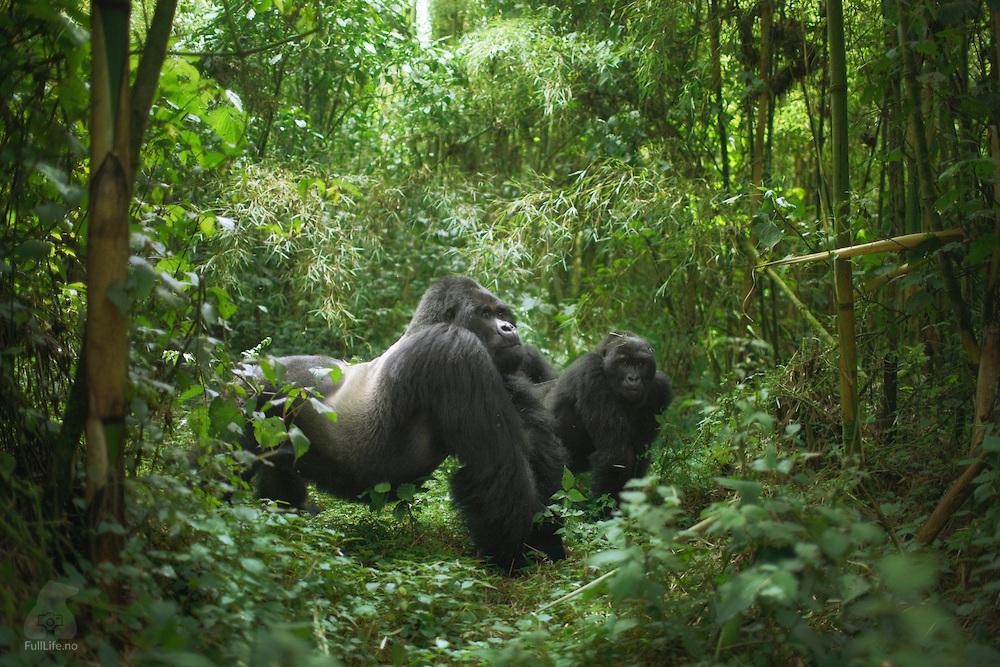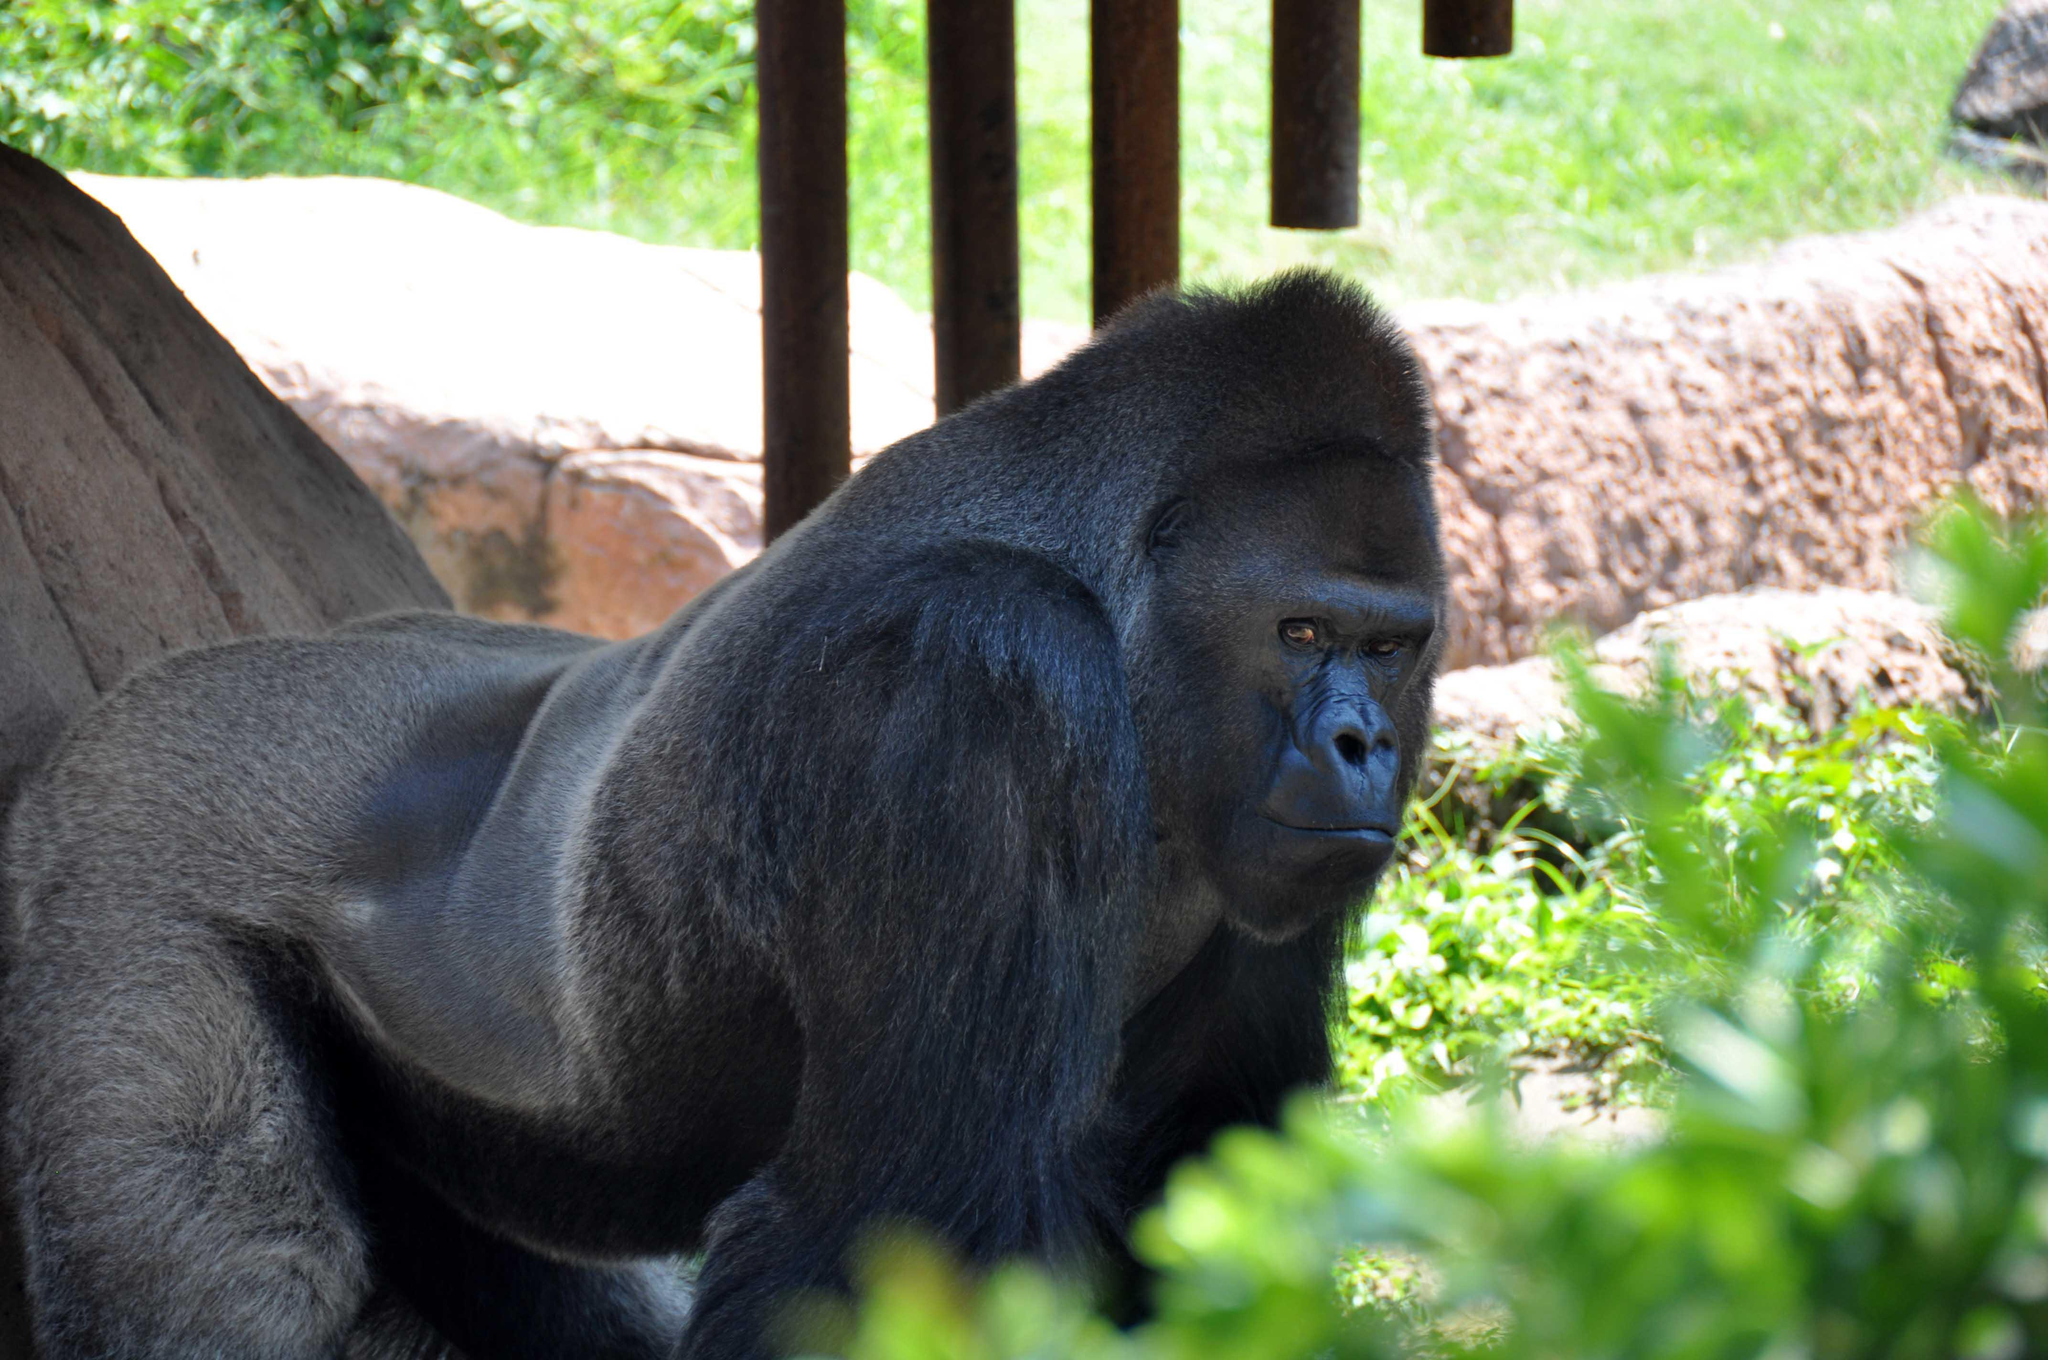The first image is the image on the left, the second image is the image on the right. Evaluate the accuracy of this statement regarding the images: "At least one images contains a very young gorilla.". Is it true? Answer yes or no. No. The first image is the image on the left, the second image is the image on the right. For the images displayed, is the sentence "There are no more than three gorillas" factually correct? Answer yes or no. Yes. 